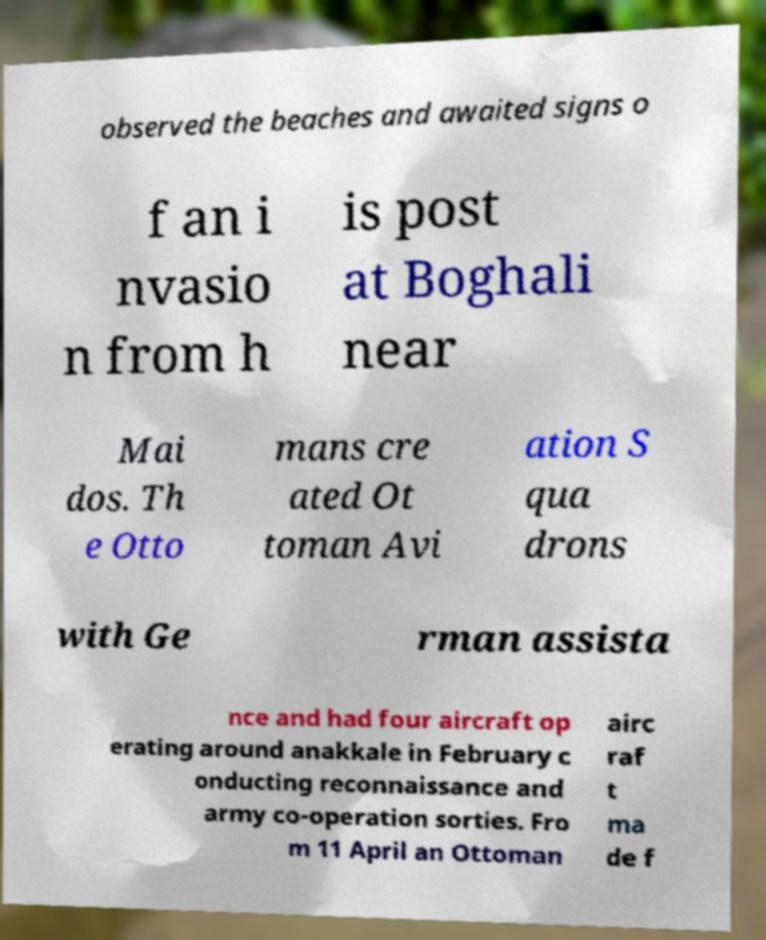What messages or text are displayed in this image? I need them in a readable, typed format. observed the beaches and awaited signs o f an i nvasio n from h is post at Boghali near Mai dos. Th e Otto mans cre ated Ot toman Avi ation S qua drons with Ge rman assista nce and had four aircraft op erating around anakkale in February c onducting reconnaissance and army co-operation sorties. Fro m 11 April an Ottoman airc raf t ma de f 